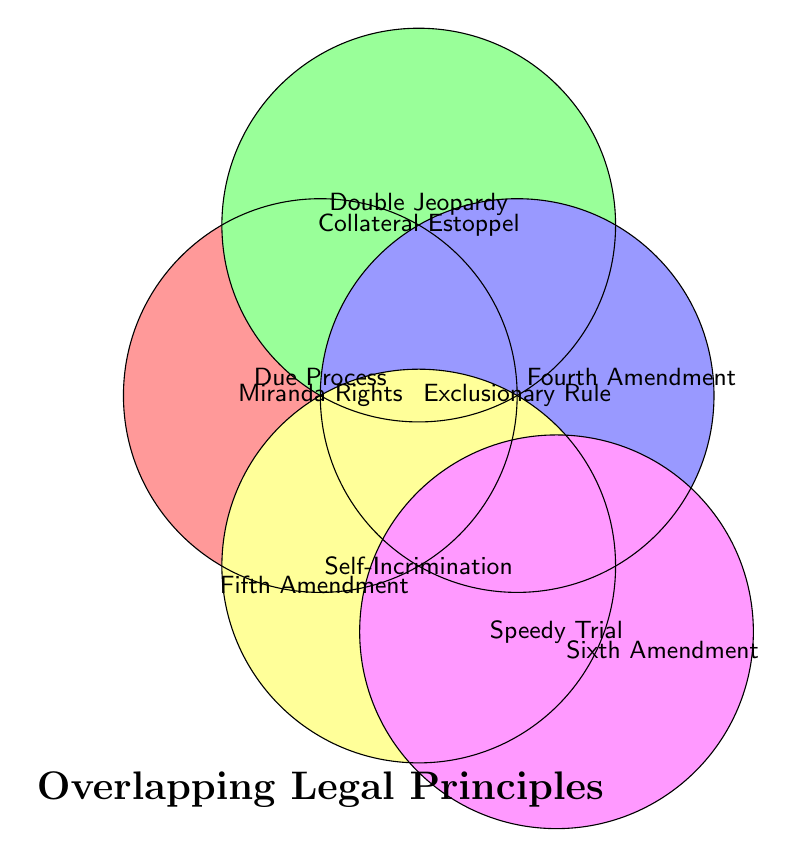What is the title of the diagram? The title is displayed at the bottom of the Venn Diagram in a larger, bold font.
Answer: Overlapping Legal Principles Which legal principle intersects with most other principles? By observing the diagram, Due Process intersects with Miranda Rights, Right to Counsel, and Presumption of Innocence, indicating it has the most intersections.
Answer: Due Process What legal principle features both 'Right to Counsel' and 'Speedy Trial'? The Sixth Amendment node contains both 'Right to Counsel' and 'Speedy Trial.'
Answer: Sixth Amendment Which two principles share the 'Miranda Rights'? 'Miranda Rights' appears at the intersection of Due Process and Fifth Amendment circles.
Answer: Due Process and Fifth Amendment Which legal principle is associated only with 'Cruel and Unusual Punishment'? 'Cruel and Unusual Punishment' is inside the circle labeled 'Eighth Amendment', with no overlaps.
Answer: Eighth Amendment What is positioned at the intersection of all sets in the Venn Diagram? The most central node within the intersecting parts of the diagram shows 'Miranda Rights.'
Answer: Miranda Rights How many principles overlap with the 'Fourth Amendment'? The Fourth Amendment shows 'Exclusionary Rule' and 'Fruit of the Poisonous Tree,' so it overlaps with at least these two.
Answer: 2 Which principle intersects both Due Process and the Sixth Amendment? The intersection of Due Process and Sixth Amendment includes 'Right to Counsel.'
Answer: Right to Counsel 